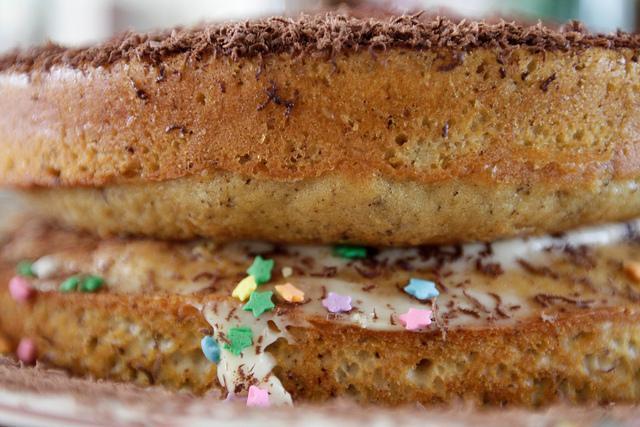How many cakes are there?
Give a very brief answer. 1. 